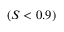<formula> <loc_0><loc_0><loc_500><loc_500>( S < 0 . 9 )</formula> 